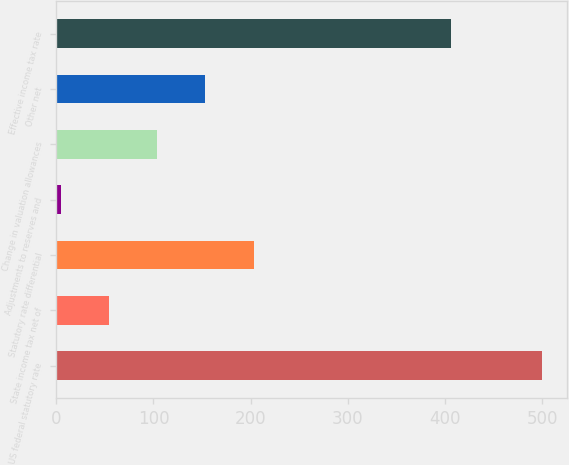<chart> <loc_0><loc_0><loc_500><loc_500><bar_chart><fcel>US federal statutory rate<fcel>State income tax net of<fcel>Statutory rate differential<fcel>Adjustments to reserves and<fcel>Change in valuation allowances<fcel>Other net<fcel>Effective income tax rate<nl><fcel>500<fcel>54.5<fcel>203<fcel>5<fcel>104<fcel>153.5<fcel>406<nl></chart> 